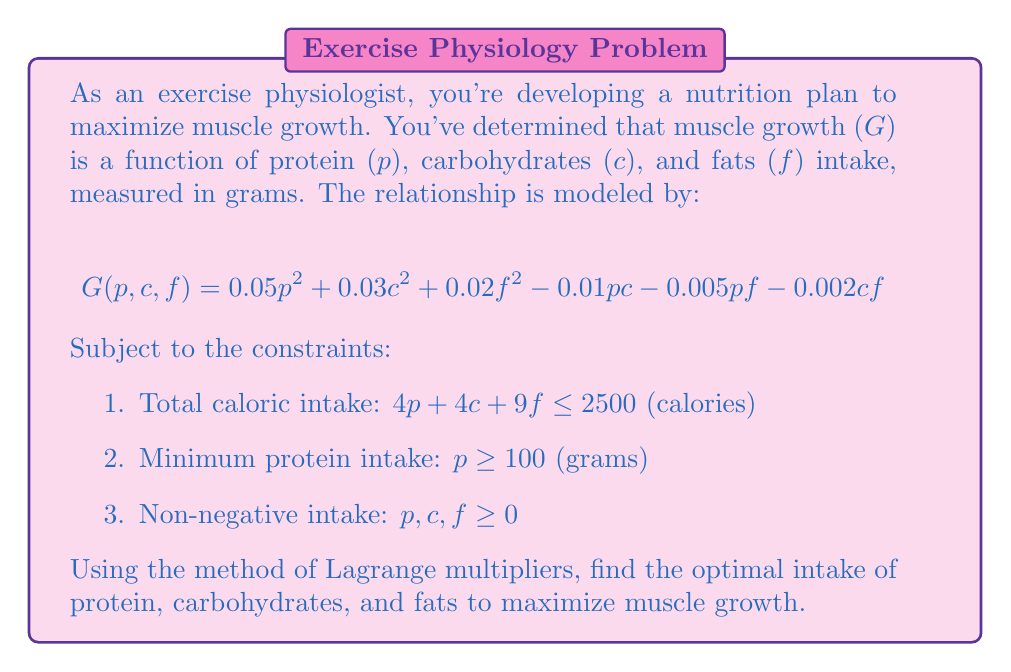Give your solution to this math problem. To solve this constrained optimization problem, we'll use the method of Lagrange multipliers:

1) First, we form the Lagrangian function:
   $$L(p,c,f,\lambda,\mu) = G(p,c,f) - \lambda(4p + 4c + 9f - 2500) - \mu(100 - p)$$

2) Now, we take partial derivatives and set them equal to zero:

   $$\frac{\partial L}{\partial p} = 0.1p - 0.01c - 0.005f - 4\lambda + \mu = 0$$
   $$\frac{\partial L}{\partial c} = 0.06c - 0.01p - 0.002f - 4\lambda = 0$$
   $$\frac{\partial L}{\partial f} = 0.04f - 0.005p - 0.002c - 9\lambda = 0$$
   $$\frac{\partial L}{\partial \lambda} = 4p + 4c + 9f - 2500 = 0$$
   $$\frac{\partial L}{\partial \mu} = 100 - p \leq 0, \mu \geq 0, \mu(100 - p) = 0$$

3) From the last equation, we see that either $p = 100$ or $\mu = 0$. Let's assume $\mu = 0$ and solve the system.

4) From the first three equations:
   $$0.1p - 0.01c - 0.005f = 4\lambda$$
   $$0.06c - 0.01p - 0.002f = 4\lambda$$
   $$0.04f - 0.005p - 0.002c = 9\lambda$$

5) Solving this system along with the calorie constraint:
   $$p \approx 156.25, c \approx 312.5, f \approx 138.89, \lambda \approx 0.625$$

6) We verify that this solution satisfies $p > 100$, so our assumption of $\mu = 0$ was correct.

7) Finally, we check that this is indeed a maximum by examining the bordered Hessian matrix (omitted for brevity).
Answer: Optimal intake: protein ≈ 156.25g, carbohydrates ≈ 312.5g, fats ≈ 138.89g 